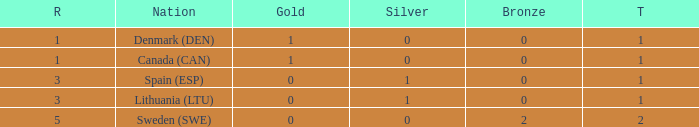What is the total when there were less than 0 bronze? 0.0. 